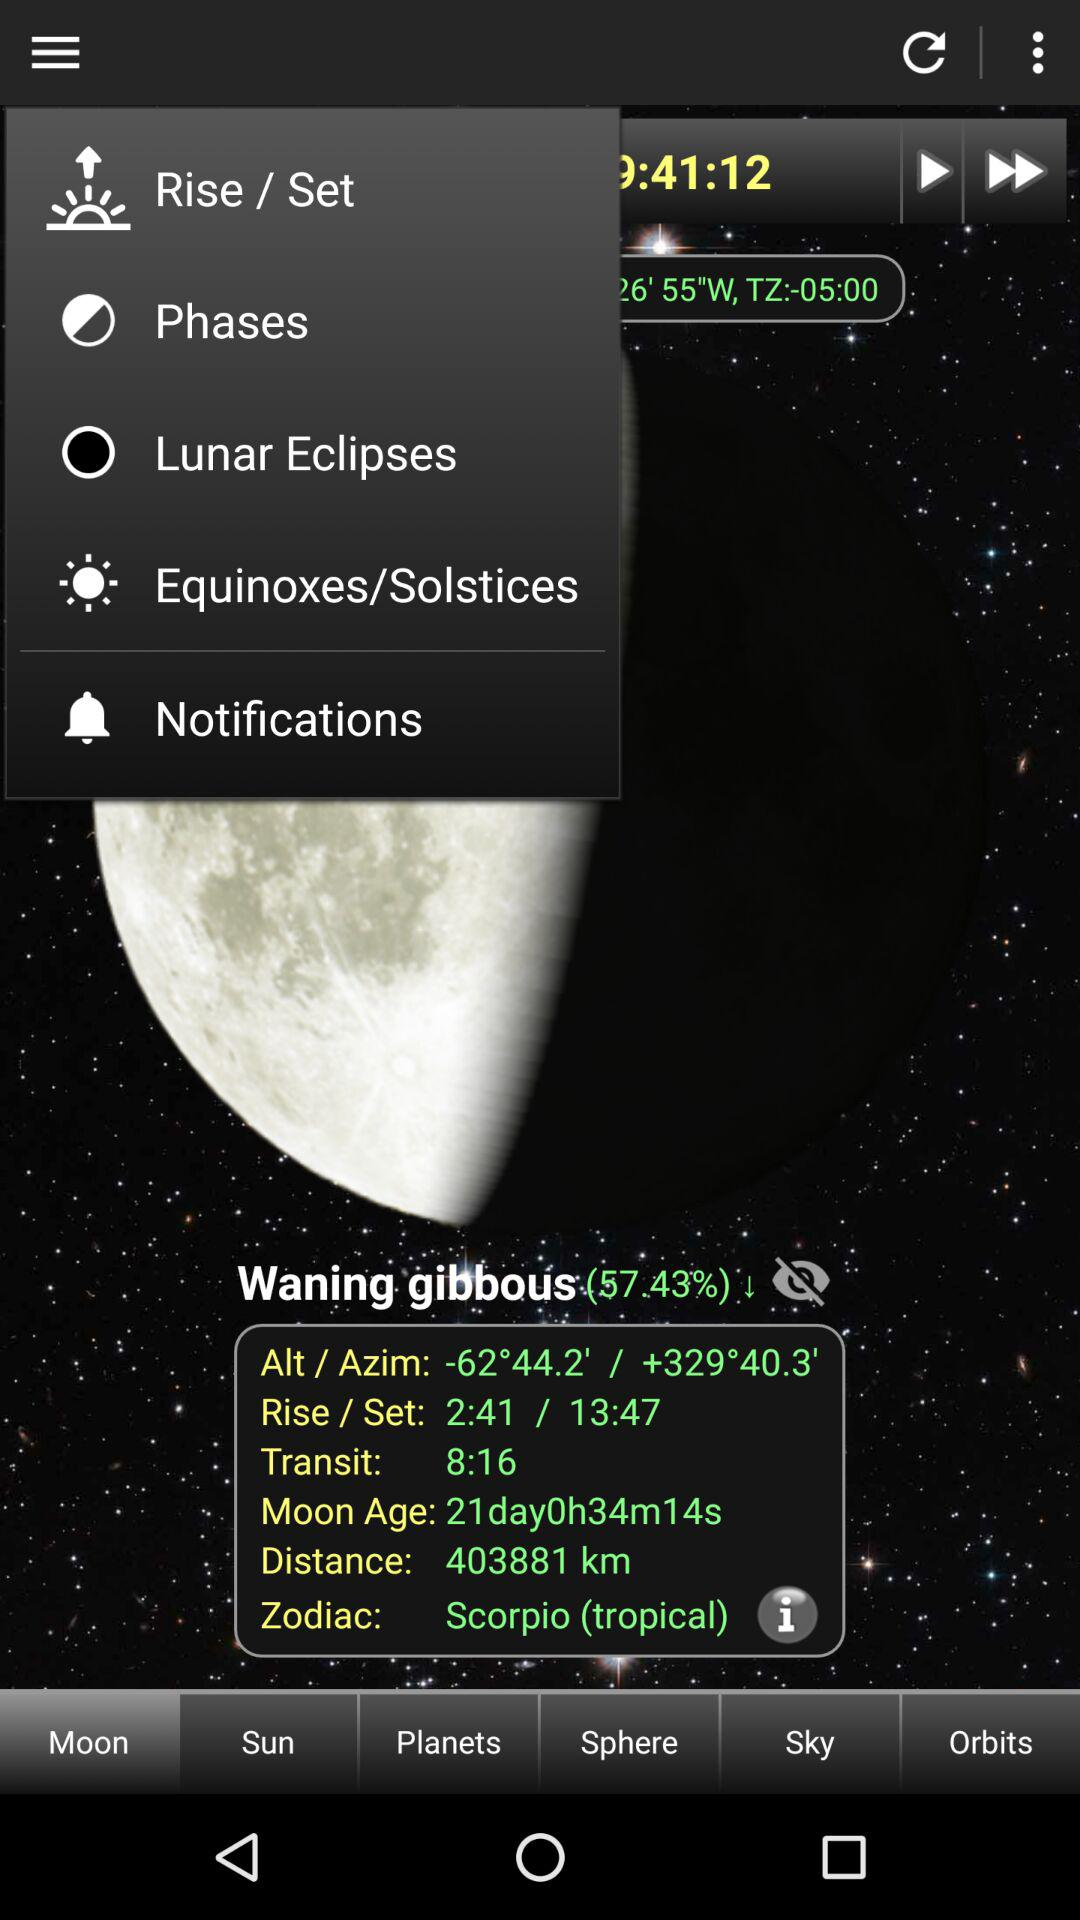What is the rising time? The rising time is 2:41. 